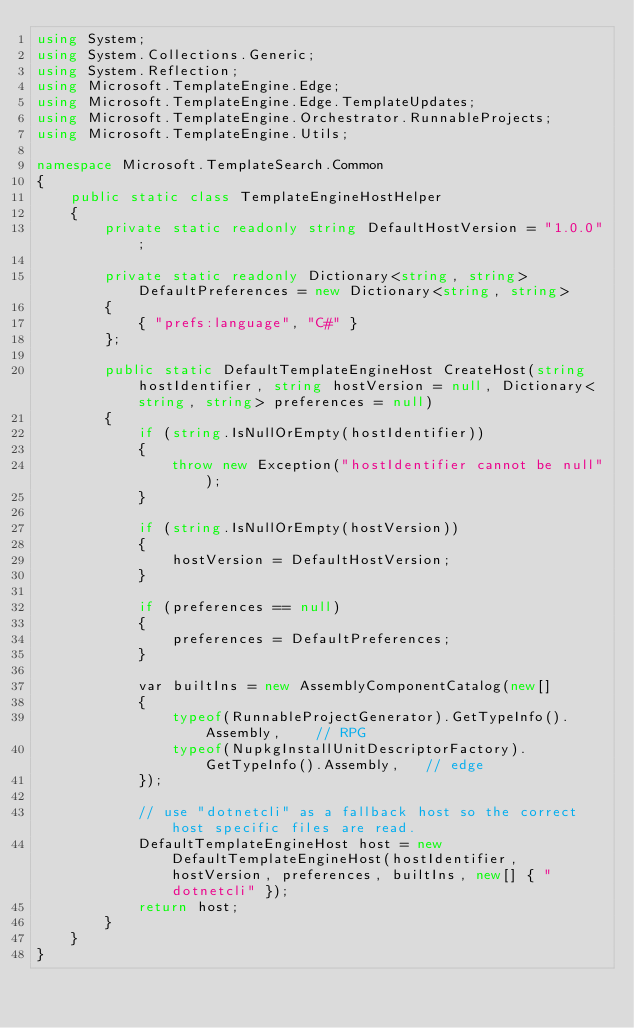Convert code to text. <code><loc_0><loc_0><loc_500><loc_500><_C#_>using System;
using System.Collections.Generic;
using System.Reflection;
using Microsoft.TemplateEngine.Edge;
using Microsoft.TemplateEngine.Edge.TemplateUpdates;
using Microsoft.TemplateEngine.Orchestrator.RunnableProjects;
using Microsoft.TemplateEngine.Utils;

namespace Microsoft.TemplateSearch.Common
{
    public static class TemplateEngineHostHelper
    {
        private static readonly string DefaultHostVersion = "1.0.0";

        private static readonly Dictionary<string, string> DefaultPreferences = new Dictionary<string, string>
        {
            { "prefs:language", "C#" }
        };

        public static DefaultTemplateEngineHost CreateHost(string hostIdentifier, string hostVersion = null, Dictionary<string, string> preferences = null)
        {
            if (string.IsNullOrEmpty(hostIdentifier))
            {
                throw new Exception("hostIdentifier cannot be null");
            }

            if (string.IsNullOrEmpty(hostVersion))
            {
                hostVersion = DefaultHostVersion;
            }

            if (preferences == null)
            {
                preferences = DefaultPreferences;
            }

            var builtIns = new AssemblyComponentCatalog(new[]
            {
                typeof(RunnableProjectGenerator).GetTypeInfo().Assembly,    // RPG
                typeof(NupkgInstallUnitDescriptorFactory).GetTypeInfo().Assembly,   // edge
            });

            // use "dotnetcli" as a fallback host so the correct host specific files are read.
            DefaultTemplateEngineHost host = new DefaultTemplateEngineHost(hostIdentifier, hostVersion, preferences, builtIns, new[] { "dotnetcli" });
            return host;
        }
    }
}
</code> 